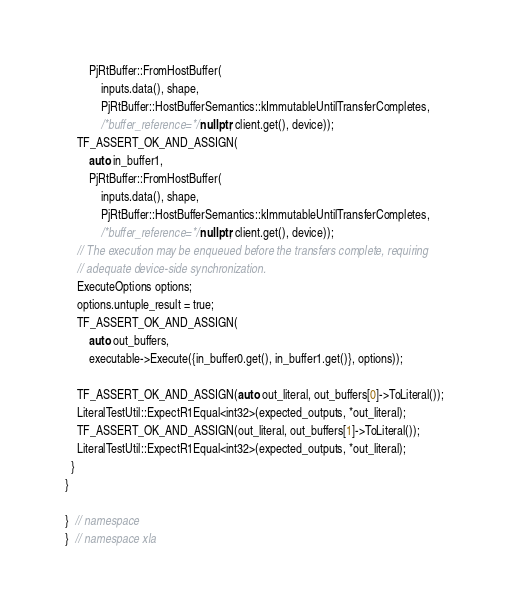Convert code to text. <code><loc_0><loc_0><loc_500><loc_500><_C++_>        PjRtBuffer::FromHostBuffer(
            inputs.data(), shape,
            PjRtBuffer::HostBufferSemantics::kImmutableUntilTransferCompletes,
            /*buffer_reference=*/nullptr, client.get(), device));
    TF_ASSERT_OK_AND_ASSIGN(
        auto in_buffer1,
        PjRtBuffer::FromHostBuffer(
            inputs.data(), shape,
            PjRtBuffer::HostBufferSemantics::kImmutableUntilTransferCompletes,
            /*buffer_reference=*/nullptr, client.get(), device));
    // The execution may be enqueued before the transfers complete, requiring
    // adequate device-side synchronization.
    ExecuteOptions options;
    options.untuple_result = true;
    TF_ASSERT_OK_AND_ASSIGN(
        auto out_buffers,
        executable->Execute({in_buffer0.get(), in_buffer1.get()}, options));

    TF_ASSERT_OK_AND_ASSIGN(auto out_literal, out_buffers[0]->ToLiteral());
    LiteralTestUtil::ExpectR1Equal<int32>(expected_outputs, *out_literal);
    TF_ASSERT_OK_AND_ASSIGN(out_literal, out_buffers[1]->ToLiteral());
    LiteralTestUtil::ExpectR1Equal<int32>(expected_outputs, *out_literal);
  }
}

}  // namespace
}  // namespace xla
</code> 